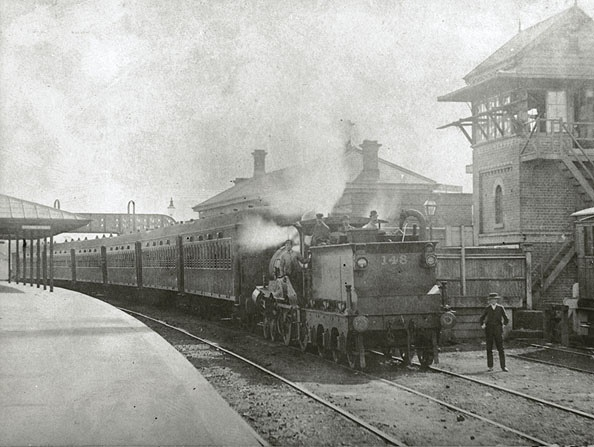Describe the objects in this image and their specific colors. I can see train in lightgray, gray, black, and darkgray tones, people in lightgray, black, gray, and darkgray tones, people in lightgray, gray, and black tones, people in lightgray, gray, and darkgray tones, and people in lightgray, darkgray, and gray tones in this image. 